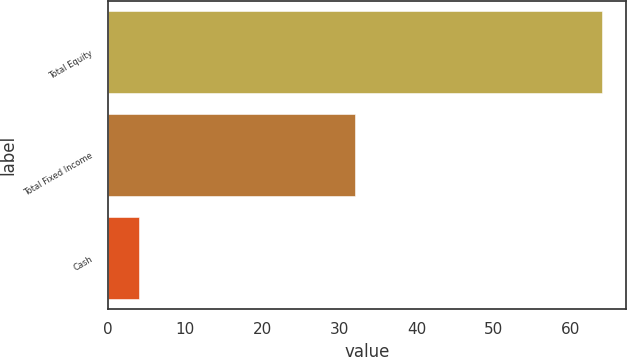Convert chart to OTSL. <chart><loc_0><loc_0><loc_500><loc_500><bar_chart><fcel>Total Equity<fcel>Total Fixed Income<fcel>Cash<nl><fcel>64<fcel>32<fcel>4<nl></chart> 